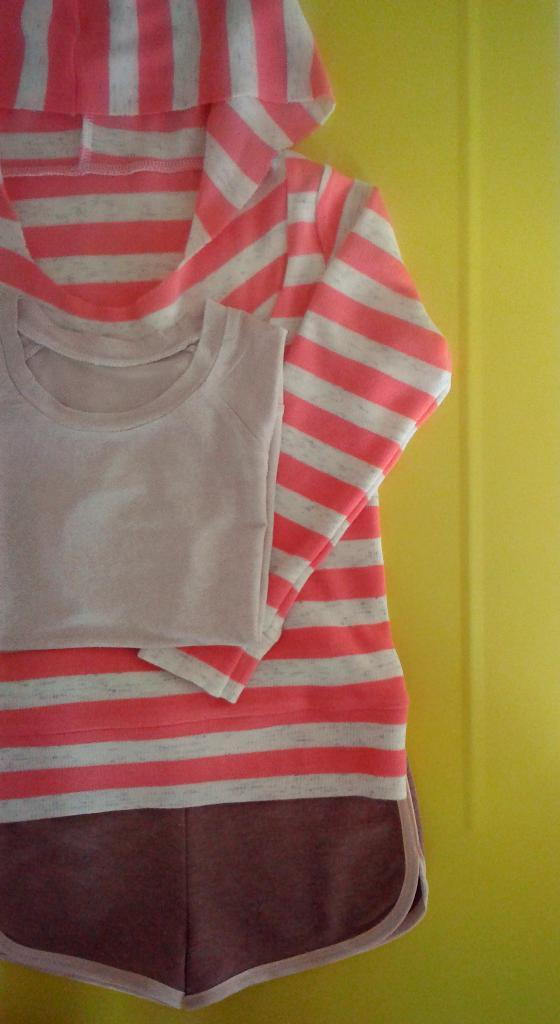What type of clothing is featured in the image? There is a cream color t-shirt and a pink and cream striped dress in the image. What is the color of the t-shirt? The t-shirt is cream color. What is the pattern of the dress? The dress has pink and cream stripes. What color is the background of the image? The background of the image is yellow in color. Is there a crook trying to steal the t-shirt in the image? No, there is no crook or any indication of theft in the image. What type of trousers are being worn by the person in the image? There is no person or trousers visible in the image; only the t-shirt and dress are present. 